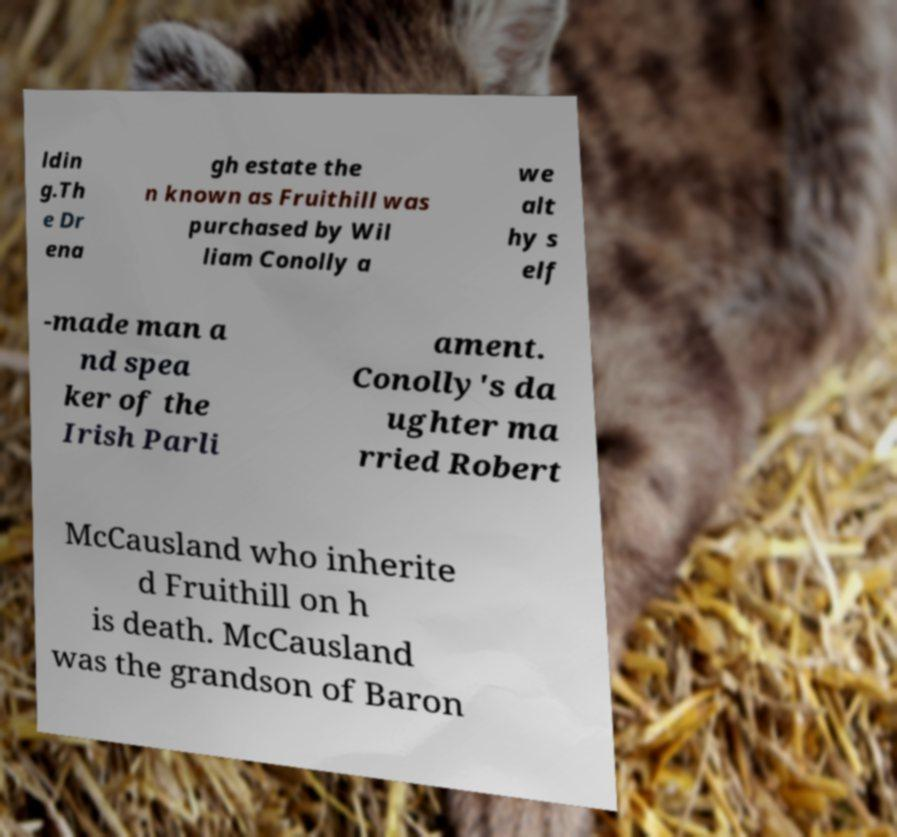Can you accurately transcribe the text from the provided image for me? ldin g.Th e Dr ena gh estate the n known as Fruithill was purchased by Wil liam Conolly a we alt hy s elf -made man a nd spea ker of the Irish Parli ament. Conolly's da ughter ma rried Robert McCausland who inherite d Fruithill on h is death. McCausland was the grandson of Baron 